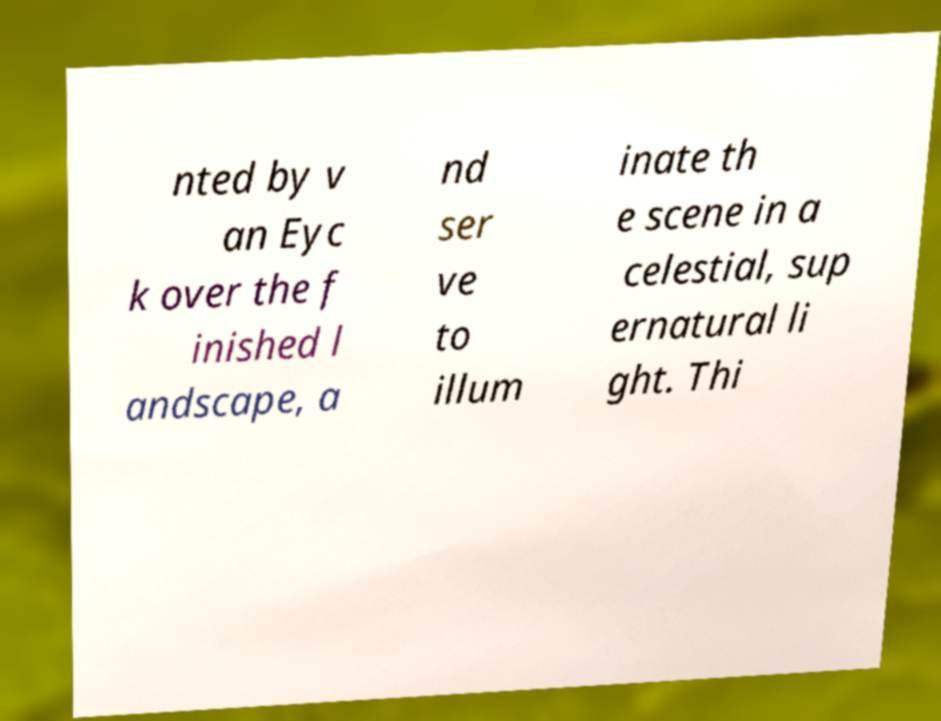Please read and relay the text visible in this image. What does it say? nted by v an Eyc k over the f inished l andscape, a nd ser ve to illum inate th e scene in a celestial, sup ernatural li ght. Thi 